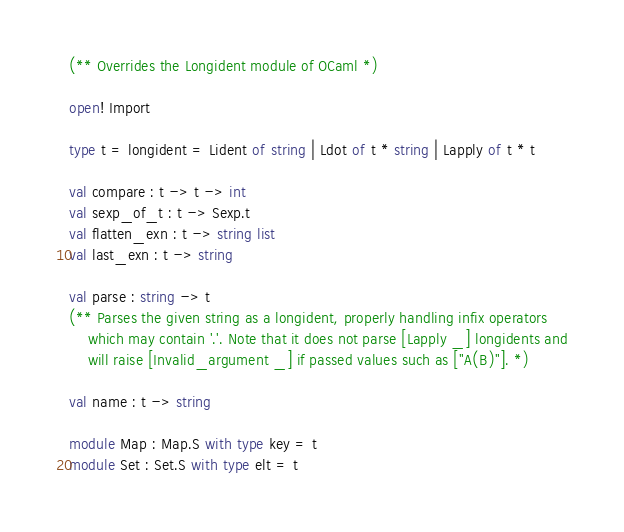<code> <loc_0><loc_0><loc_500><loc_500><_OCaml_>(** Overrides the Longident module of OCaml *)

open! Import

type t = longident = Lident of string | Ldot of t * string | Lapply of t * t

val compare : t -> t -> int
val sexp_of_t : t -> Sexp.t
val flatten_exn : t -> string list
val last_exn : t -> string

val parse : string -> t
(** Parses the given string as a longident, properly handling infix operators
    which may contain '.'. Note that it does not parse [Lapply _] longidents and
    will raise [Invalid_argument _] if passed values such as ["A(B)"]. *)

val name : t -> string

module Map : Map.S with type key = t
module Set : Set.S with type elt = t
</code> 